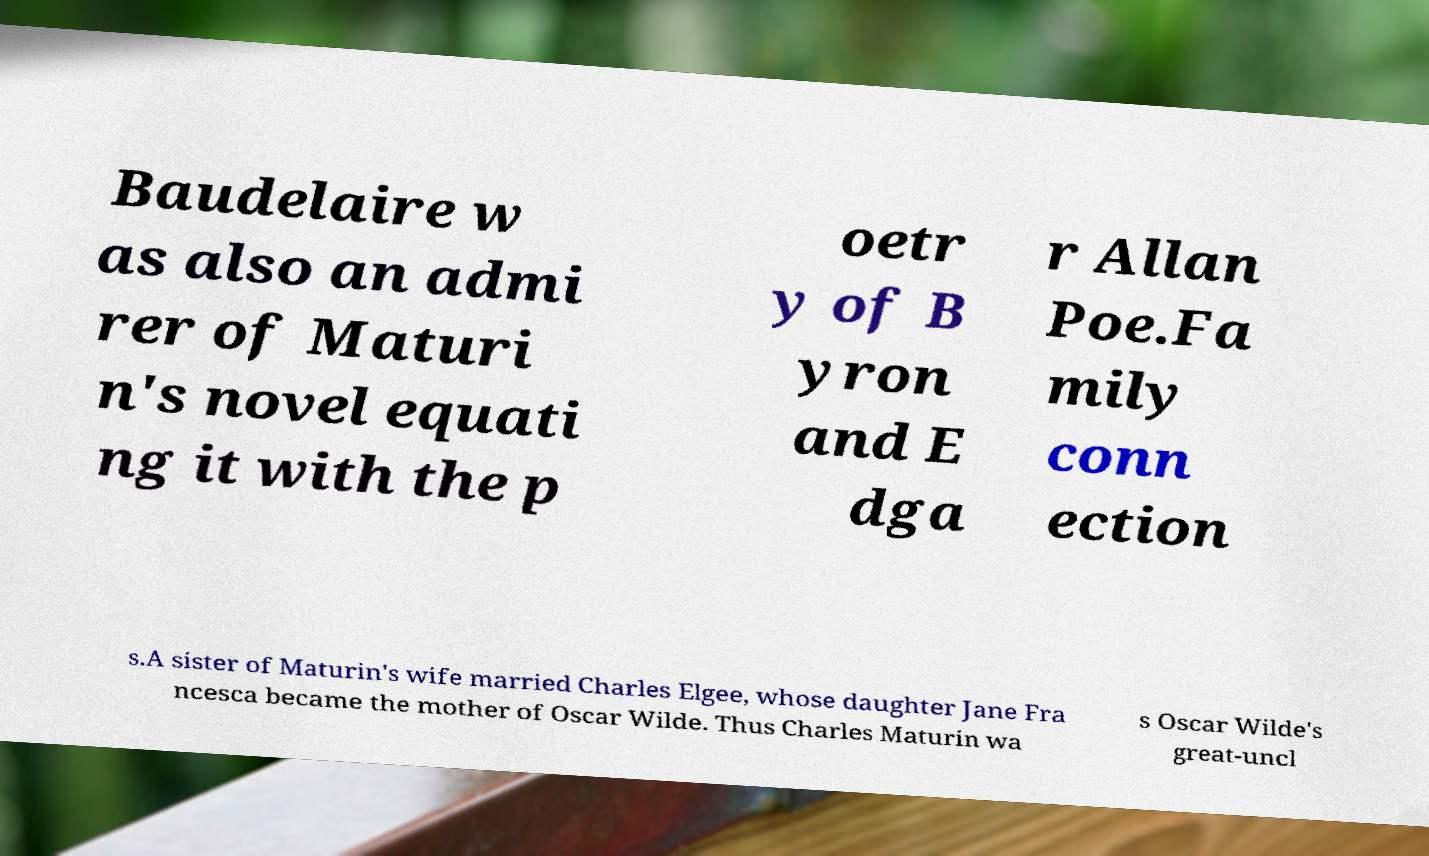I need the written content from this picture converted into text. Can you do that? Baudelaire w as also an admi rer of Maturi n's novel equati ng it with the p oetr y of B yron and E dga r Allan Poe.Fa mily conn ection s.A sister of Maturin's wife married Charles Elgee, whose daughter Jane Fra ncesca became the mother of Oscar Wilde. Thus Charles Maturin wa s Oscar Wilde's great-uncl 